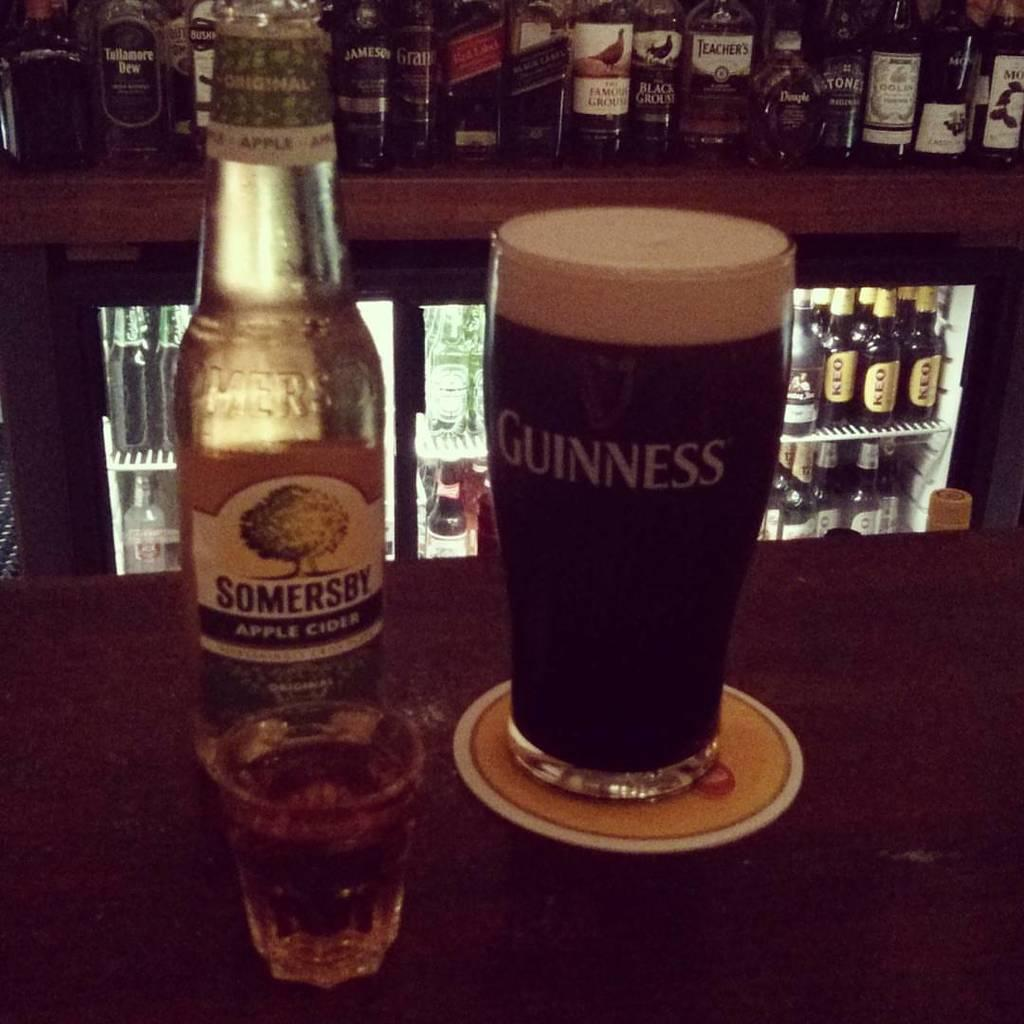<image>
Give a short and clear explanation of the subsequent image. A guinness glass filled with a beer sits on a coaster. 